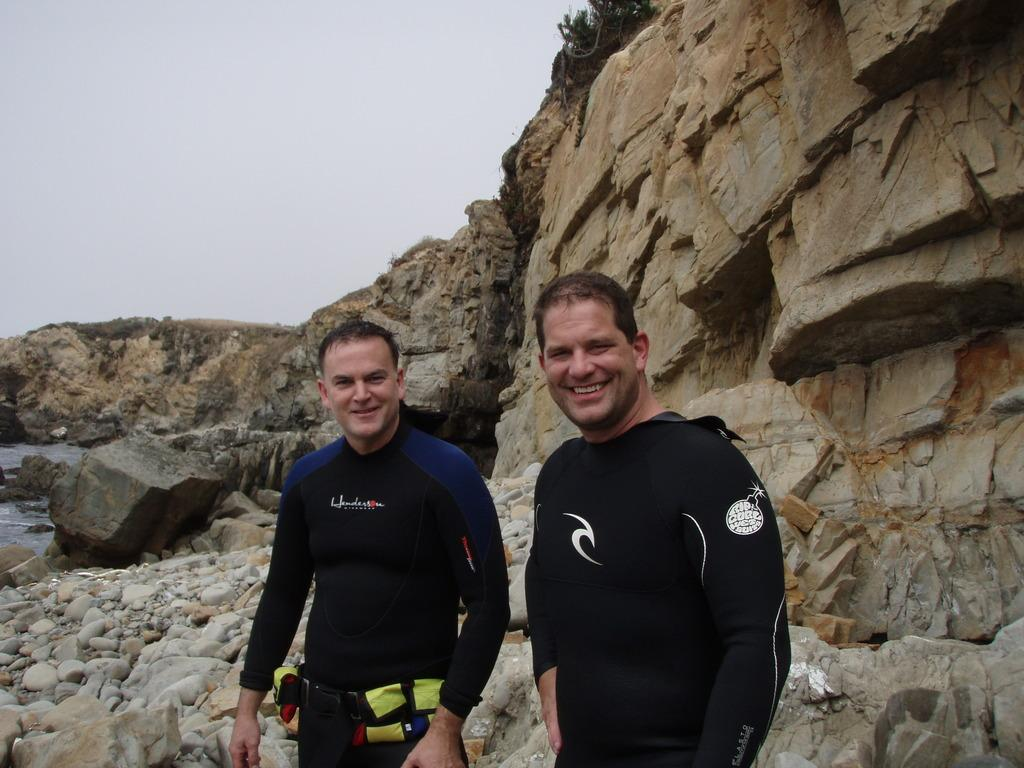How many people are in the image? There are two men in the image. What are the men standing beside in the image? The men are standing beside mountains in the image. What type of terrain can be seen in the image? There are stones and water visible in the image. How would you describe the weather in the image? The sky is cloudy in the image, suggesting a potentially overcast or rainy day. Can you see a crook in the hands of one of the men in the image? There is no crook present in the image; the men are standing beside mountains. What type of window can be seen in the image? There is no window present in the image; it features two men standing beside mountains. 